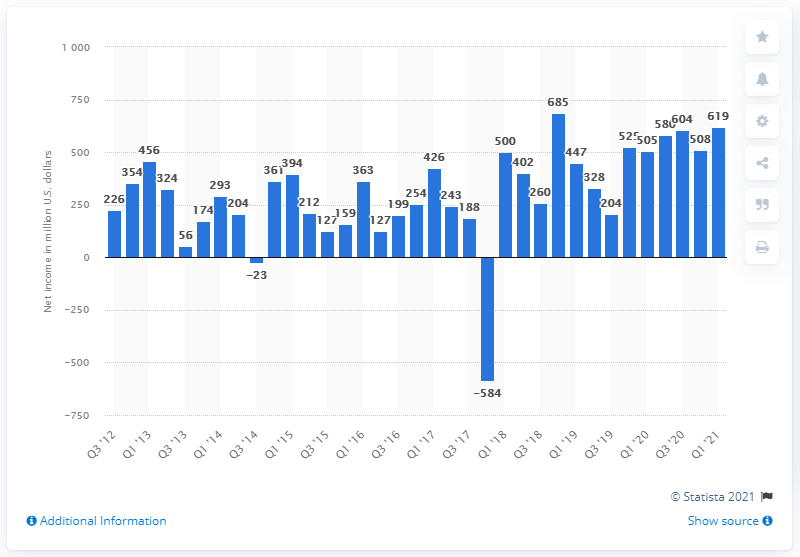Outline some significant characteristics in this image. Activision Blizzard's net income in the first quarter of 2021 was 619 million dollars. 